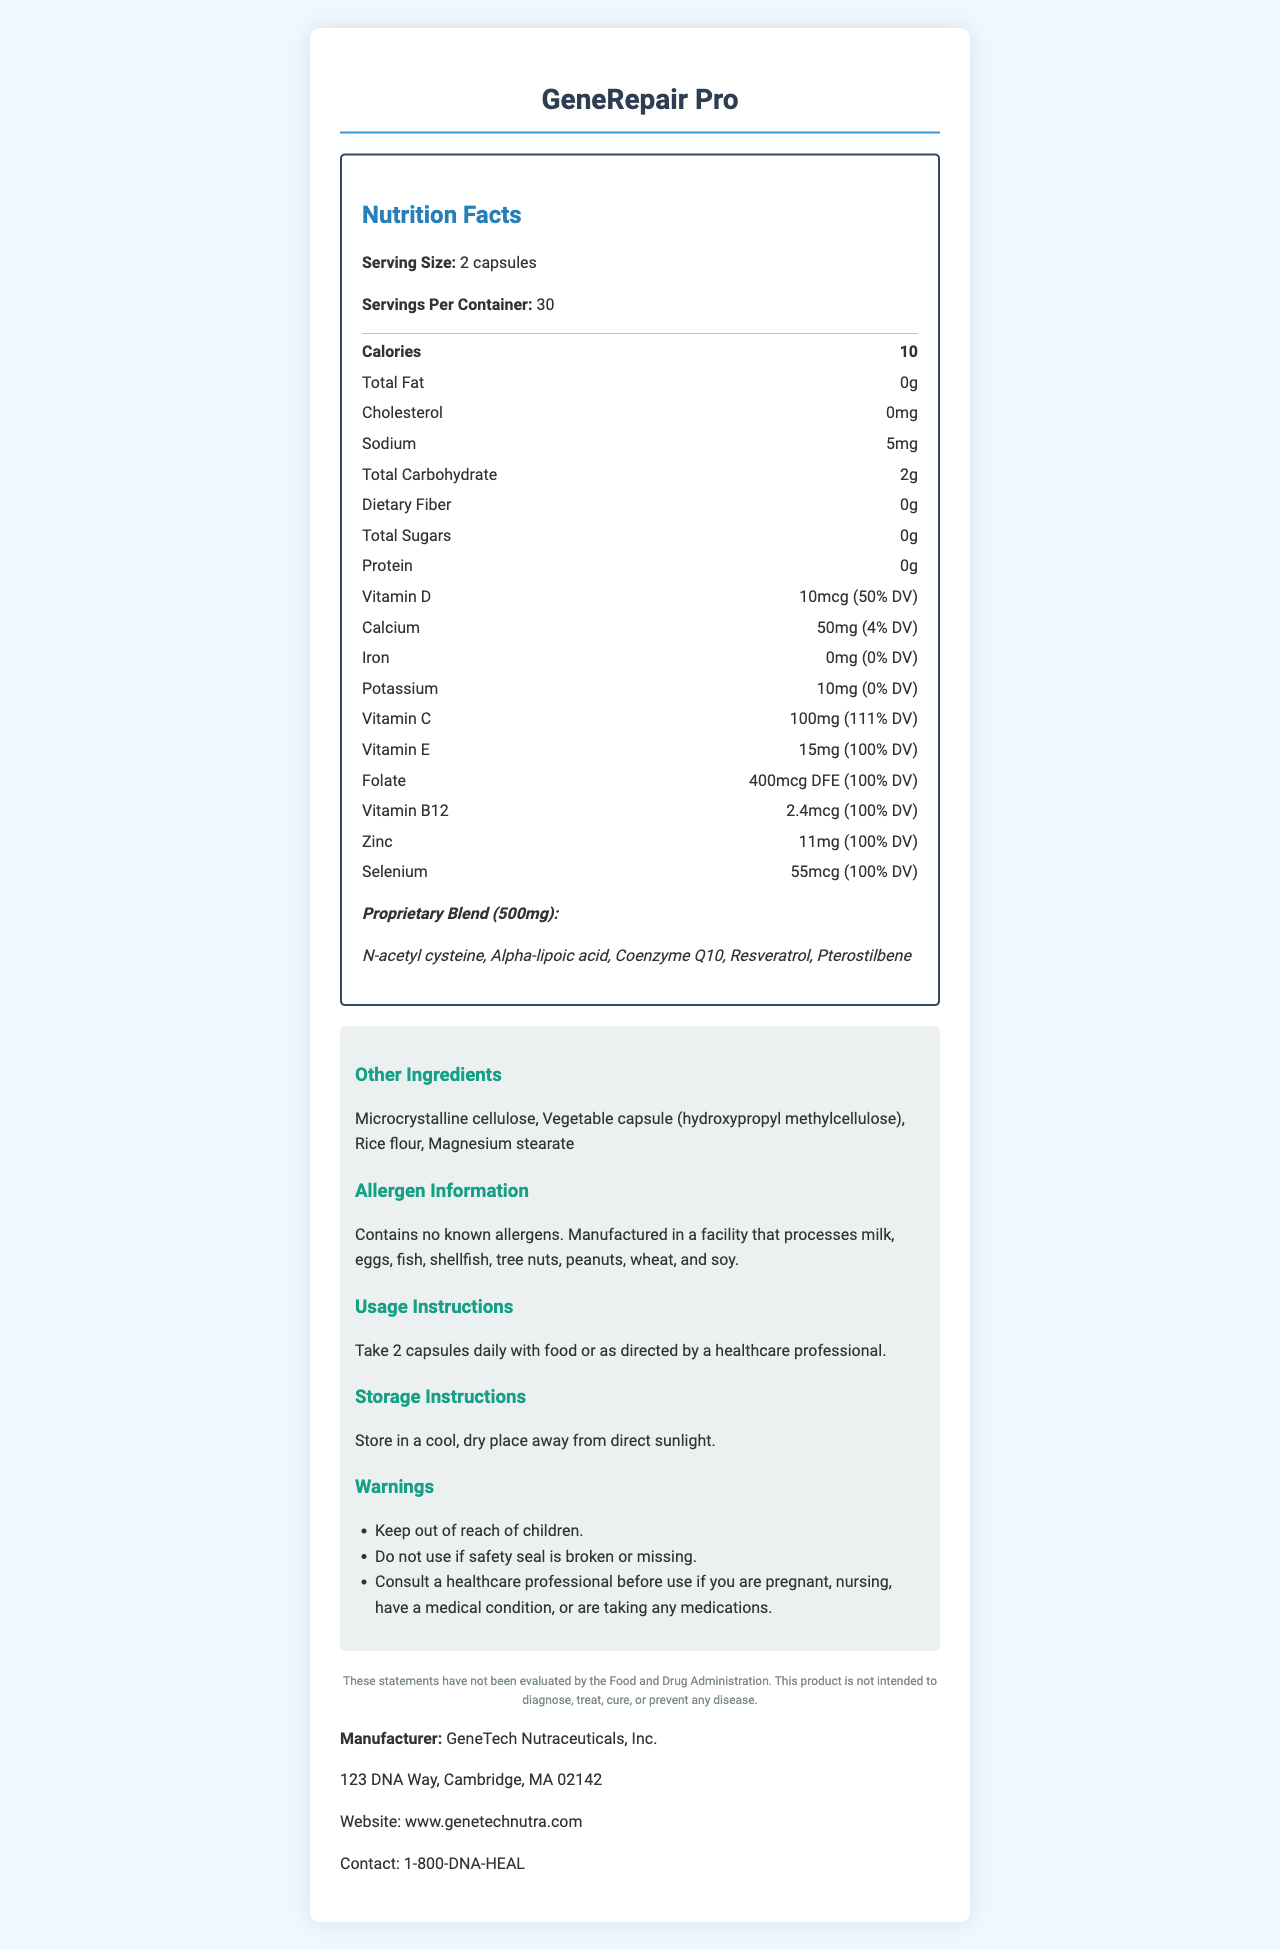what is the serving size of GeneRepair Pro? The serving size is specified at the beginning of the nutrition facts section of the document.
Answer: 2 capsules how many servings are in one container of GeneRepair Pro? This information is listed right after the serving size in the document.
Answer: 30 servings per container how many calories are there per serving? This can be found under the nutrition facts, where calories are listed.
Answer: 10 calories what is the proprietary blend amount in GeneRepair Pro? This is noted in the proprietary blend section of the nutrition facts.
Answer: 500mg which vitamins in GeneRepair Pro provide 100% of the daily value (DV)? The percentages of DV for each of these vitamins are listed next to their respective names.
Answer: Vitamin E, Folate, Vitamin B12, Zinc, Selenium how many grams of total fat does GeneRepair Pro contain? The total fat content is listed as 0g in the nutrition facts section.
Answer: 0g what is the main ingredient in the vegetable capsule? A. Microcrystalline cellulose B. Hydroxypropyl methylcellulose C. Rice flour D. Magnesium stearate It is stated in the list of other ingredients where it mentions the vegetable capsule (hydroxypropyl methylcellulose).
Answer: B. Hydroxypropyl methylcellulose what is the total carbohydrate content in a serving of GeneRepair Pro? A. 0g B. 2g C. 5mg D. 10mg This information is available in the nutrition facts section under total carbohydrate.
Answer: B. 2g does GeneRepair Pro contain any allergens? This detail is given under the allergen information section.
Answer: No, but it is manufactured in a facility that processes other allergens should pregnant women consult a healthcare professional before taking GeneRepair Pro? This is mentioned in the warnings section.
Answer: Yes what is the main function of GeneRepair Pro as stated on the label? This is implied by the product name and its nutrient composition designed for these purposes.
Answer: DNA repair and cellular health is GeneRepair Pro suitable for someone with a shellfish allergy? The allergen information states that it contains no known allergens.
Answer: Yes describe the entire document. The explanation follows the layout and contents of the document, describing the structure and the kind of information provided in each section.
Answer: The document is a detailed nutrition facts label for GeneRepair Pro, a dietary supplement designed for DNA repair and cellular health. It includes information on serving size, servings per container, calories, and various nutrients. Key ingredients like vitamins, minerals, and a proprietary blend are listed along with their daily value percentages. It also provides details on other ingredients, allergen information, usage and storage instructions, warnings, and a disclaimer. Manufacturer information and contact details are included at the end. what is the effect of taking GeneRepair Pro on genetic disorders? The label does not provide any information related to the effects of GeneRepair Pro on genetic disorders. The disclaimer also mentions the product is not intended to diagnose, treat, cure, or prevent any disease.
Answer: Cannot be determined 